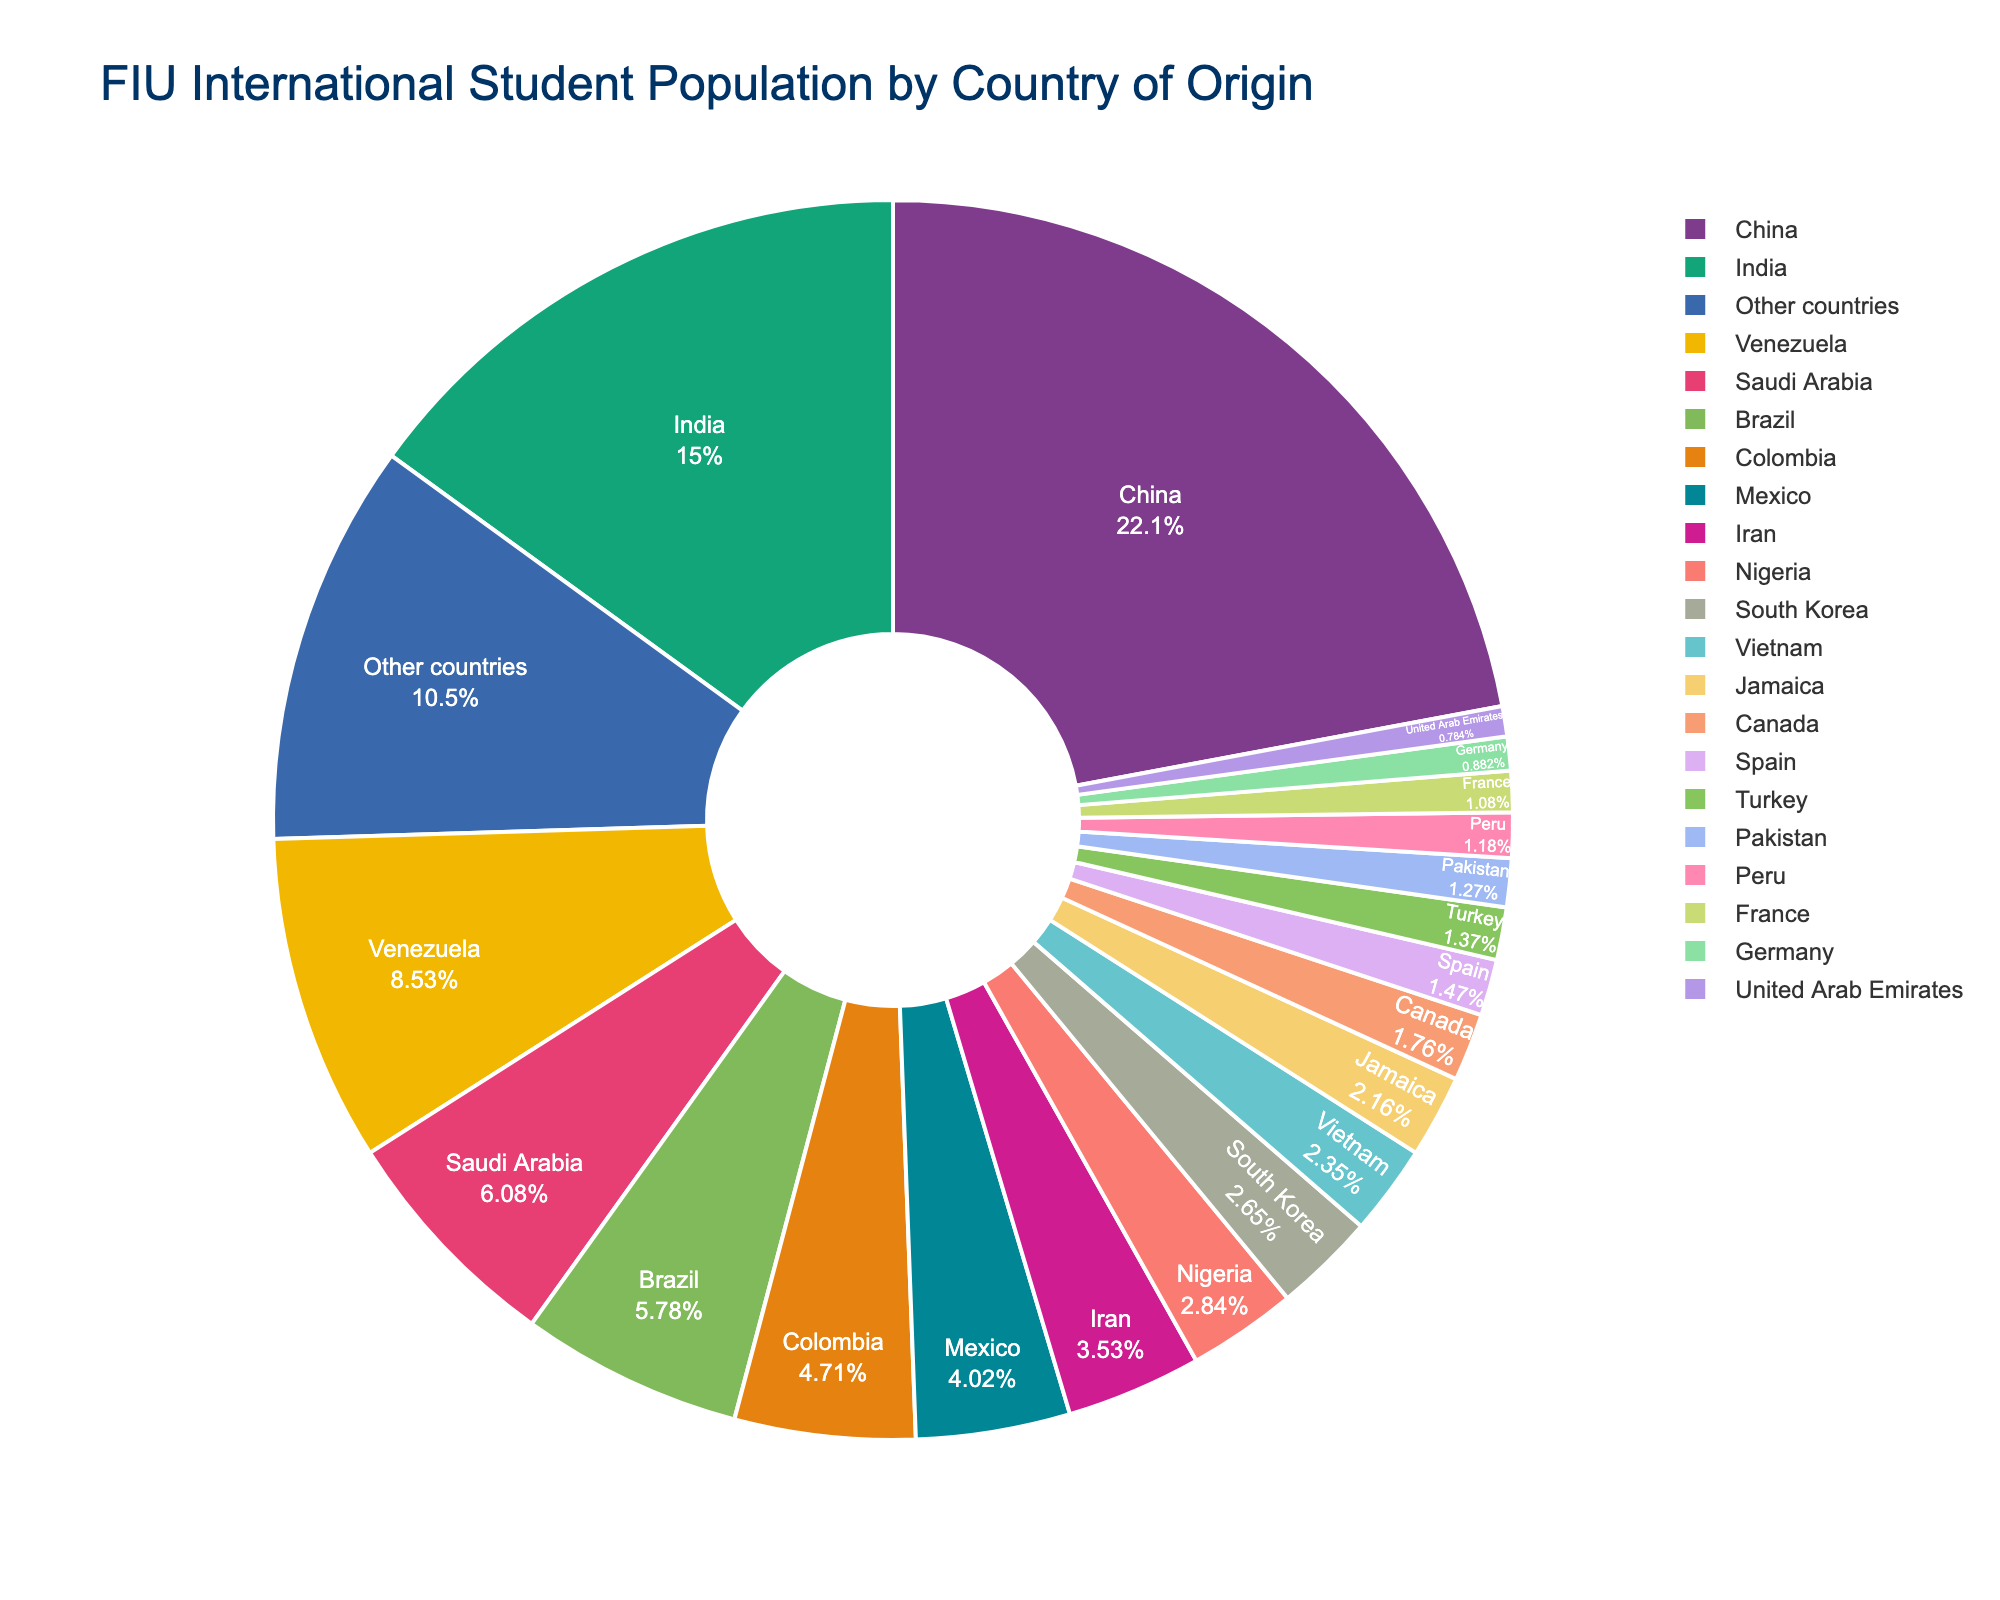what percentage of FIU's international student population comes from China? The pie chart has a section labeled "China" that shows the percentage directly.
Answer: 22.5% Which country contributes the least to FIU's international student population, and what percentage is it? The pie chart has a section labeled "United Arab Emirates" with the smallest percentage displayed.
Answer: United Arab Emirates, 0.8% How much larger is the percentage of students from China compared to students from India? The percentage of students from China is 22.5%, and the percentage from India is 15.3%. Subtract the smaller percentage from the larger one to get the difference: 22.5% - 15.3%.
Answer: 7.2% What is the combined percentage of students from Mexico, Vietnam, and Jamaica? To find the combined percentage, add the percentages for Mexico (4.1%), Vietnam (2.4%), and Jamaica (2.2%): 4.1% + 2.4% + 2.2%.
Answer: 8.7% Which country has a larger percentage of students at FIU, Brazil or Saudi Arabia, and by how much? Brazil's percentage is 5.9% and Saudi Arabia's percentage is 6.2%. Subtract Brazil's percentage from Saudi Arabia's percentage to find the difference: 6.2% - 5.9%.
Answer: Saudi Arabia, by 0.3% What is the average percentage of students from the top three countries? The top three countries are China (22.5%), India (15.3%), and Venezuela (8.7%). Calculate the average by summing the percentages and dividing by three: (22.5% + 15.3% + 8.7%) / 3.
Answer: 15.5% How many countries contribute more than 5% each to FIU's international student population? Visually identify the segments of the pie chart that have percentages greater than 5%. There are five such countries: China, India, Venezuela, Saudi Arabia, and Brazil.
Answer: 5 What is the total percentage of students coming from countries other than the top 10 listed? Other countries account for a separate section in the pie chart labeled "Other countries" with a percentage. This section is 10.7%.
Answer: 10.7% Between Colombia and Nigeria, which country contributes a higher percentage, and what is the difference? Colombia contributes 4.8% and Nigeria contributes 2.9%. Subtract Nigeria's percentage from Colombia's: 4.8% - 2.9%.
Answer: Colombia, by 1.9% Identify the percentage of students from countries in the Americas (Venezuela, Brazil, Colombia, Mexico, Jamaica, Canada, Peru). Add the percentages from Venezuela (8.7%), Brazil (5.9%), Colombia (4.8%), Mexico (4.1%), Jamaica (2.2%), Canada (1.8%), and Peru (1.2%): 8.7% + 5.9% + 4.8% + 4.1% + 2.2% + 1.8% + 1.2%.
Answer: 28.7% 